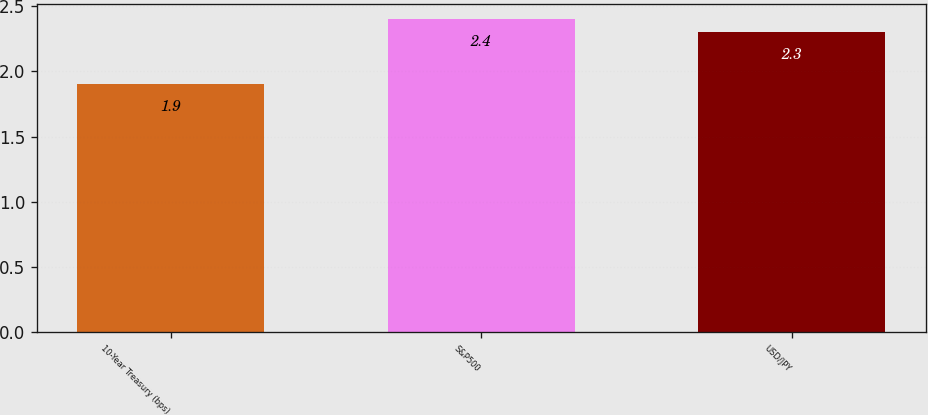Convert chart. <chart><loc_0><loc_0><loc_500><loc_500><bar_chart><fcel>10-Year Treasury (bps)<fcel>S&P500<fcel>USD/JPY<nl><fcel>1.9<fcel>2.4<fcel>2.3<nl></chart> 